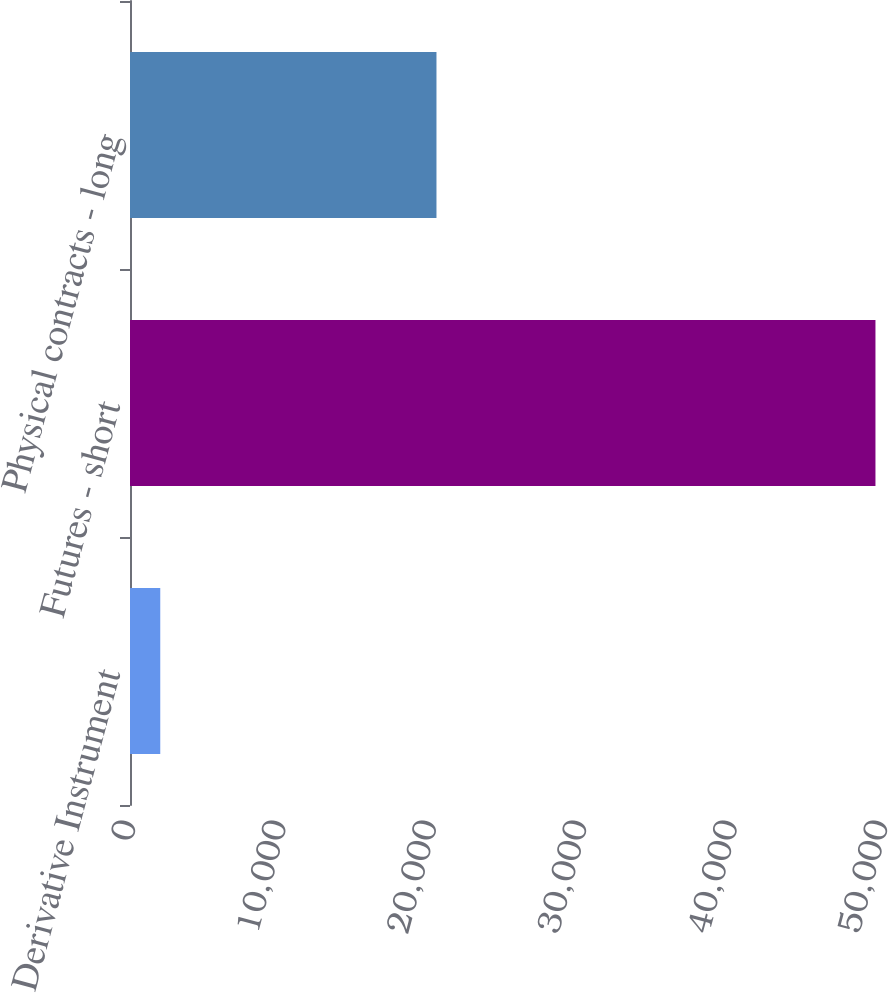Convert chart to OTSL. <chart><loc_0><loc_0><loc_500><loc_500><bar_chart><fcel>Derivative Instrument<fcel>Futures - short<fcel>Physical contracts - long<nl><fcel>2012<fcel>49565<fcel>20377<nl></chart> 